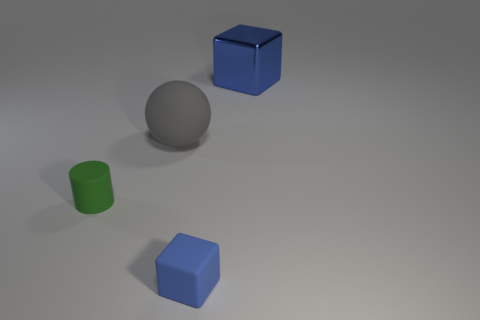Does the image provide any clue about texture? While the objects themselves bear no distinct texture, the matte finish of the shapes suggests a non-glossy surface, which contrasts with the slightly reflective nature of the ball. 